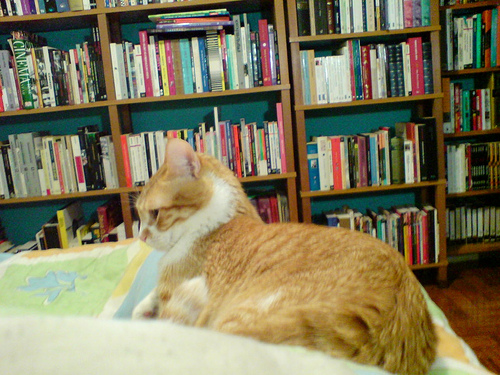<image>
Is the cat on the sofa? Yes. Looking at the image, I can see the cat is positioned on top of the sofa, with the sofa providing support. 